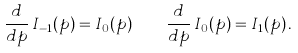Convert formula to latex. <formula><loc_0><loc_0><loc_500><loc_500>\frac { d } { d p } \, I _ { - 1 } ( p ) = I _ { 0 } ( p ) \quad \frac { d } { d p } \, I _ { 0 } ( p ) = I _ { 1 } ( p ) \, .</formula> 